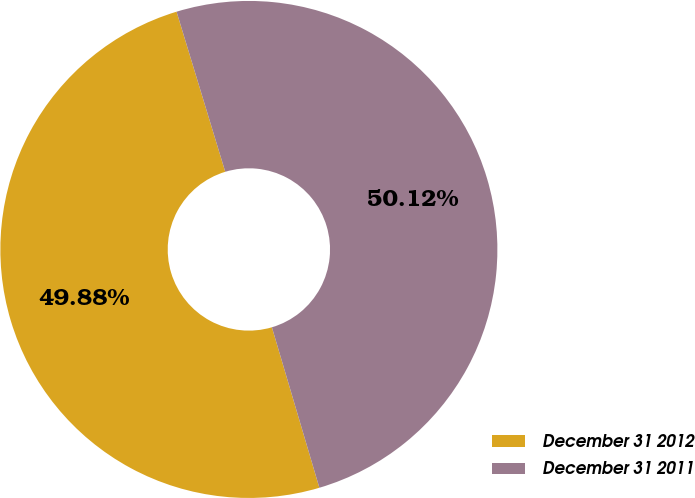Convert chart. <chart><loc_0><loc_0><loc_500><loc_500><pie_chart><fcel>December 31 2012<fcel>December 31 2011<nl><fcel>49.88%<fcel>50.12%<nl></chart> 